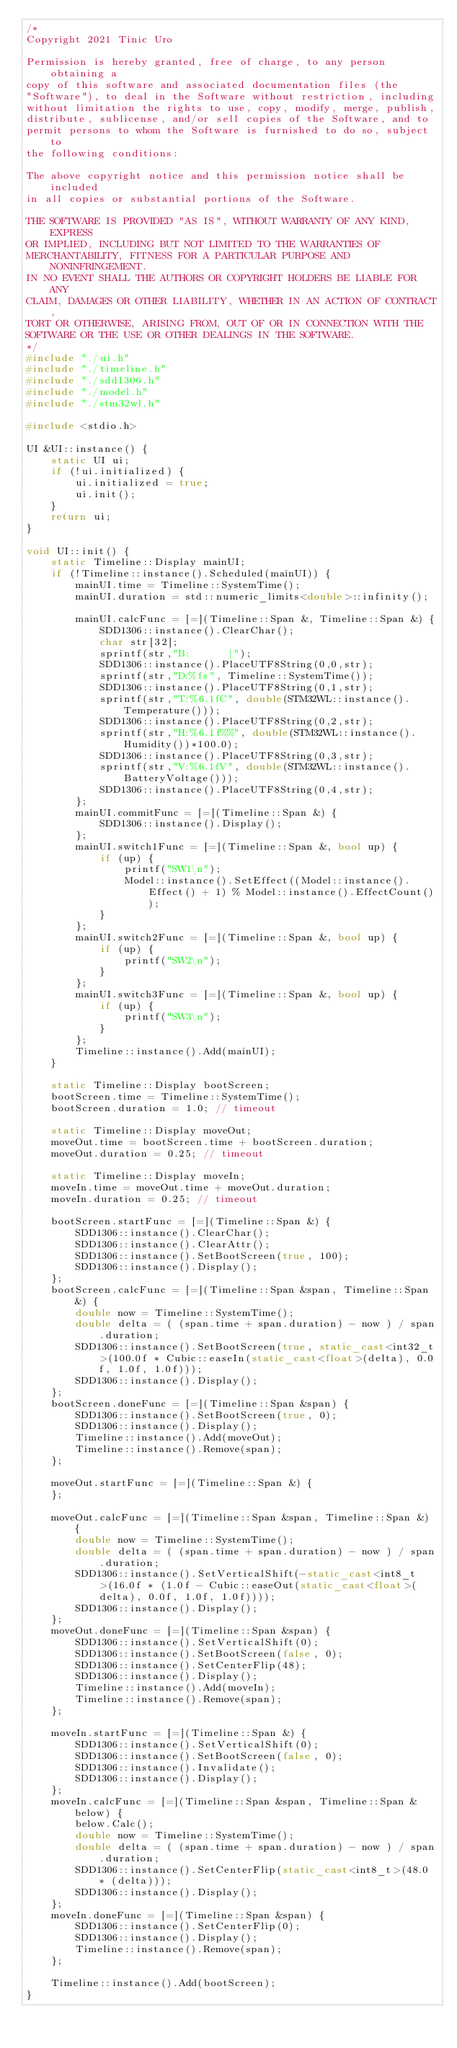Convert code to text. <code><loc_0><loc_0><loc_500><loc_500><_C++_>/*
Copyright 2021 Tinic Uro

Permission is hereby granted, free of charge, to any person obtaining a
copy of this software and associated documentation files (the
"Software"), to deal in the Software without restriction, including
without limitation the rights to use, copy, modify, merge, publish,
distribute, sublicense, and/or sell copies of the Software, and to
permit persons to whom the Software is furnished to do so, subject to
the following conditions:

The above copyright notice and this permission notice shall be included
in all copies or substantial portions of the Software.

THE SOFTWARE IS PROVIDED "AS IS", WITHOUT WARRANTY OF ANY KIND, EXPRESS
OR IMPLIED, INCLUDING BUT NOT LIMITED TO THE WARRANTIES OF
MERCHANTABILITY, FITNESS FOR A PARTICULAR PURPOSE AND NONINFRINGEMENT.
IN NO EVENT SHALL THE AUTHORS OR COPYRIGHT HOLDERS BE LIABLE FOR ANY
CLAIM, DAMAGES OR OTHER LIABILITY, WHETHER IN AN ACTION OF CONTRACT,
TORT OR OTHERWISE, ARISING FROM, OUT OF OR IN CONNECTION WITH THE
SOFTWARE OR THE USE OR OTHER DEALINGS IN THE SOFTWARE.
*/
#include "./ui.h"
#include "./timeline.h"
#include "./sdd1306.h"
#include "./model.h"
#include "./stm32wl.h"

#include <stdio.h>

UI &UI::instance() {
    static UI ui;
    if (!ui.initialized) {
        ui.initialized = true;
        ui.init();
    }
    return ui;
}

void UI::init() {
    static Timeline::Display mainUI;
    if (!Timeline::instance().Scheduled(mainUI)) {
        mainUI.time = Timeline::SystemTime();
        mainUI.duration = std::numeric_limits<double>::infinity();

        mainUI.calcFunc = [=](Timeline::Span &, Timeline::Span &) {
            SDD1306::instance().ClearChar();
            char str[32];
            sprintf(str,"B:      |");
            SDD1306::instance().PlaceUTF8String(0,0,str);
            sprintf(str,"D:%fs", Timeline::SystemTime());
            SDD1306::instance().PlaceUTF8String(0,1,str);
            sprintf(str,"T:%6.1fC", double(STM32WL::instance().Temperature()));
            SDD1306::instance().PlaceUTF8String(0,2,str);
            sprintf(str,"H:%6.1f%%", double(STM32WL::instance().Humidity())*100.0);
            SDD1306::instance().PlaceUTF8String(0,3,str);
            sprintf(str,"V:%6.1fV", double(STM32WL::instance().BatteryVoltage()));
            SDD1306::instance().PlaceUTF8String(0,4,str);
        };
        mainUI.commitFunc = [=](Timeline::Span &) {
            SDD1306::instance().Display();
        };
        mainUI.switch1Func = [=](Timeline::Span &, bool up) {
            if (up) { 
                printf("SW1\n");
                Model::instance().SetEffect((Model::instance().Effect() + 1) % Model::instance().EffectCount());
            }
        };
        mainUI.switch2Func = [=](Timeline::Span &, bool up) {
            if (up) { 
                printf("SW2\n");
            }
        };
        mainUI.switch3Func = [=](Timeline::Span &, bool up) {
            if (up) { 
                printf("SW3\n");
            }
        };
        Timeline::instance().Add(mainUI);
    }

    static Timeline::Display bootScreen;
    bootScreen.time = Timeline::SystemTime();
    bootScreen.duration = 1.0; // timeout

    static Timeline::Display moveOut;
    moveOut.time = bootScreen.time + bootScreen.duration;
    moveOut.duration = 0.25; // timeout

    static Timeline::Display moveIn;
    moveIn.time = moveOut.time + moveOut.duration;
    moveIn.duration = 0.25; // timeout

    bootScreen.startFunc = [=](Timeline::Span &) {
        SDD1306::instance().ClearChar();
        SDD1306::instance().ClearAttr();
        SDD1306::instance().SetBootScreen(true, 100);
        SDD1306::instance().Display();
    };
    bootScreen.calcFunc = [=](Timeline::Span &span, Timeline::Span &) {
        double now = Timeline::SystemTime();
        double delta = ( (span.time + span.duration) - now ) / span.duration;
        SDD1306::instance().SetBootScreen(true, static_cast<int32_t>(100.0f * Cubic::easeIn(static_cast<float>(delta), 0.0f, 1.0f, 1.0f)));
        SDD1306::instance().Display();
    };
    bootScreen.doneFunc = [=](Timeline::Span &span) {
        SDD1306::instance().SetBootScreen(true, 0);
        SDD1306::instance().Display();
        Timeline::instance().Add(moveOut);
        Timeline::instance().Remove(span);
    };

    moveOut.startFunc = [=](Timeline::Span &) {
    };

    moveOut.calcFunc = [=](Timeline::Span &span, Timeline::Span &) {
        double now = Timeline::SystemTime();
        double delta = ( (span.time + span.duration) - now ) / span.duration;
        SDD1306::instance().SetVerticalShift(-static_cast<int8_t>(16.0f * (1.0f - Cubic::easeOut(static_cast<float>(delta), 0.0f, 1.0f, 1.0f))));
        SDD1306::instance().Display();
    };
    moveOut.doneFunc = [=](Timeline::Span &span) {
        SDD1306::instance().SetVerticalShift(0);
        SDD1306::instance().SetBootScreen(false, 0);
        SDD1306::instance().SetCenterFlip(48);
        SDD1306::instance().Display();
        Timeline::instance().Add(moveIn);
        Timeline::instance().Remove(span);
    };

    moveIn.startFunc = [=](Timeline::Span &) {
        SDD1306::instance().SetVerticalShift(0);
        SDD1306::instance().SetBootScreen(false, 0);
        SDD1306::instance().Invalidate();
        SDD1306::instance().Display();
    };
    moveIn.calcFunc = [=](Timeline::Span &span, Timeline::Span &below) {
        below.Calc();
        double now = Timeline::SystemTime();
        double delta = ( (span.time + span.duration) - now ) / span.duration;
        SDD1306::instance().SetCenterFlip(static_cast<int8_t>(48.0 * (delta)));
        SDD1306::instance().Display();
    };
    moveIn.doneFunc = [=](Timeline::Span &span) {
        SDD1306::instance().SetCenterFlip(0);
        SDD1306::instance().Display();
        Timeline::instance().Remove(span);
    };

    Timeline::instance().Add(bootScreen);
}
</code> 